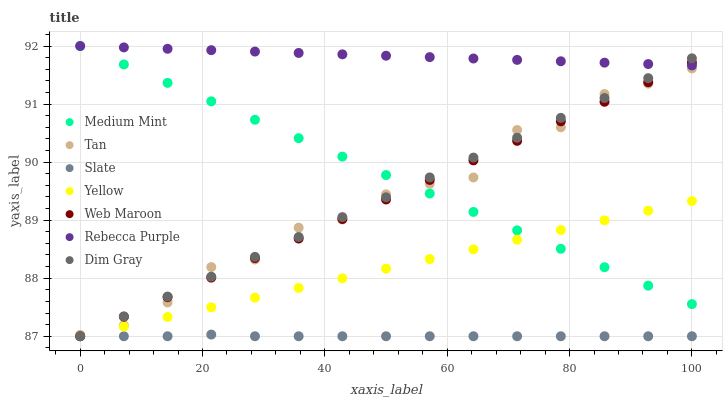Does Slate have the minimum area under the curve?
Answer yes or no. Yes. Does Rebecca Purple have the maximum area under the curve?
Answer yes or no. Yes. Does Dim Gray have the minimum area under the curve?
Answer yes or no. No. Does Dim Gray have the maximum area under the curve?
Answer yes or no. No. Is Medium Mint the smoothest?
Answer yes or no. Yes. Is Tan the roughest?
Answer yes or no. Yes. Is Dim Gray the smoothest?
Answer yes or no. No. Is Dim Gray the roughest?
Answer yes or no. No. Does Dim Gray have the lowest value?
Answer yes or no. Yes. Does Rebecca Purple have the lowest value?
Answer yes or no. No. Does Rebecca Purple have the highest value?
Answer yes or no. Yes. Does Dim Gray have the highest value?
Answer yes or no. No. Is Slate less than Tan?
Answer yes or no. Yes. Is Tan greater than Slate?
Answer yes or no. Yes. Does Web Maroon intersect Yellow?
Answer yes or no. Yes. Is Web Maroon less than Yellow?
Answer yes or no. No. Is Web Maroon greater than Yellow?
Answer yes or no. No. Does Slate intersect Tan?
Answer yes or no. No. 